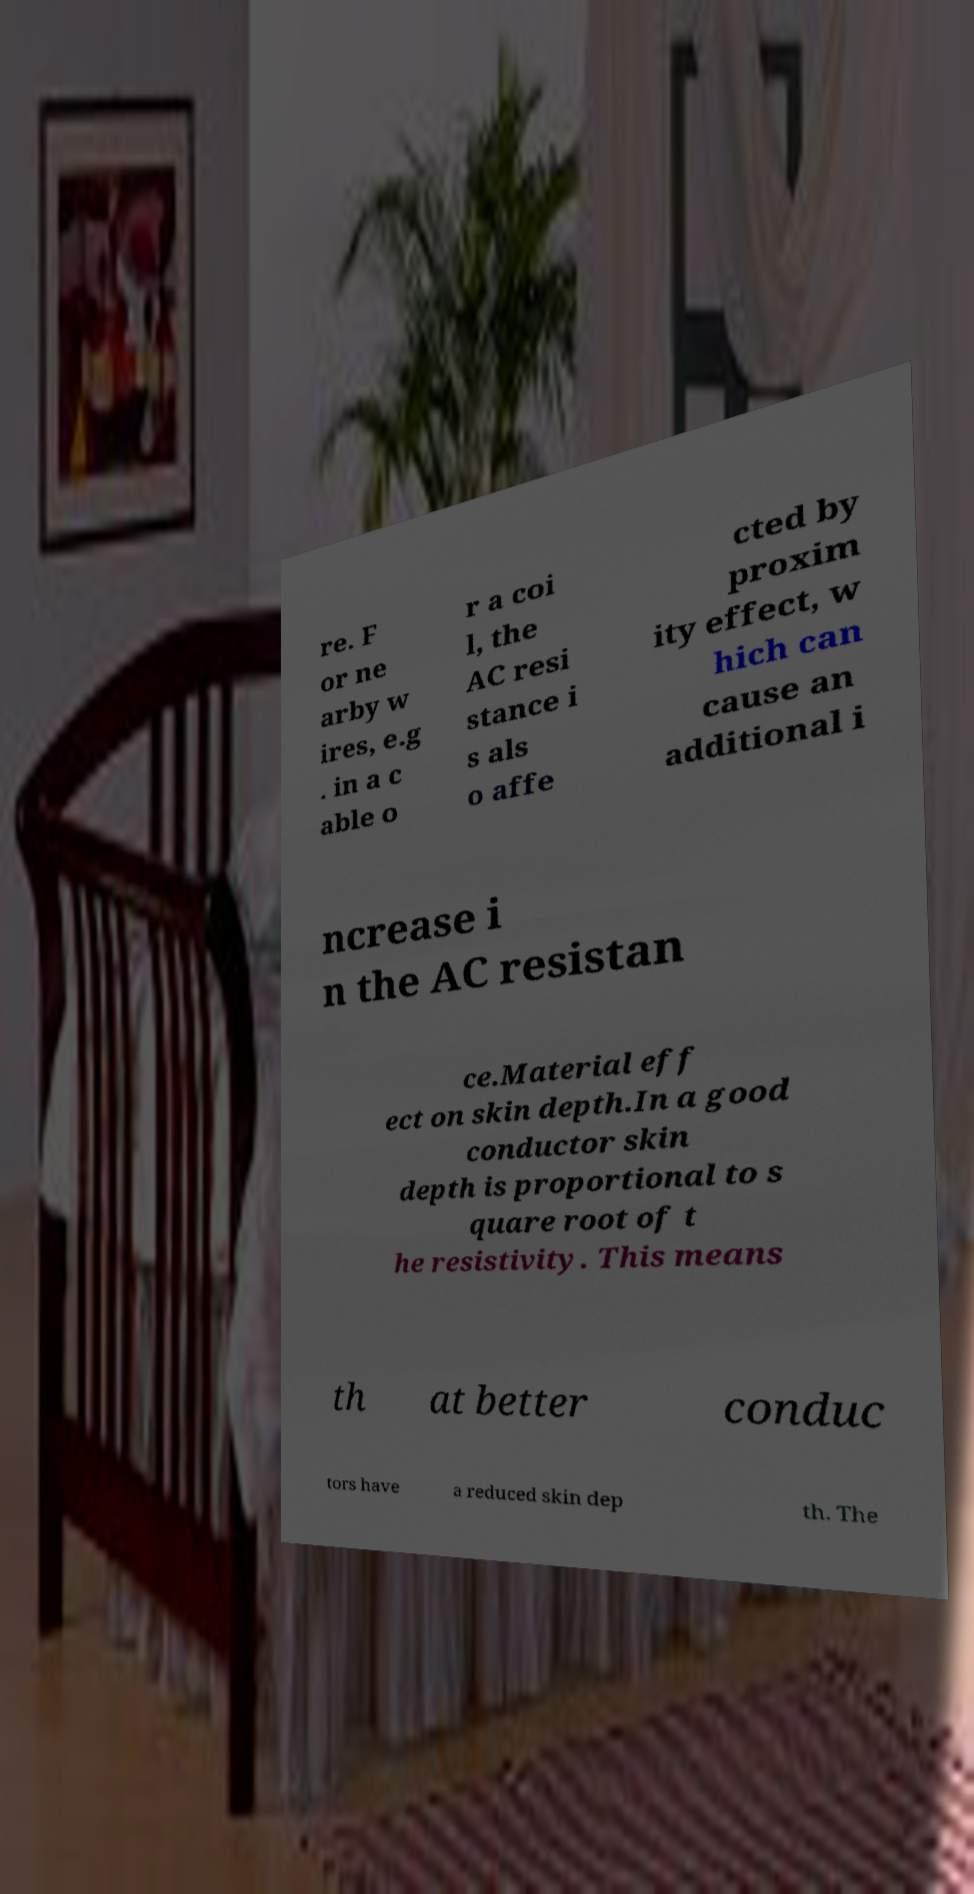Could you assist in decoding the text presented in this image and type it out clearly? re. F or ne arby w ires, e.g . in a c able o r a coi l, the AC resi stance i s als o affe cted by proxim ity effect, w hich can cause an additional i ncrease i n the AC resistan ce.Material eff ect on skin depth.In a good conductor skin depth is proportional to s quare root of t he resistivity. This means th at better conduc tors have a reduced skin dep th. The 